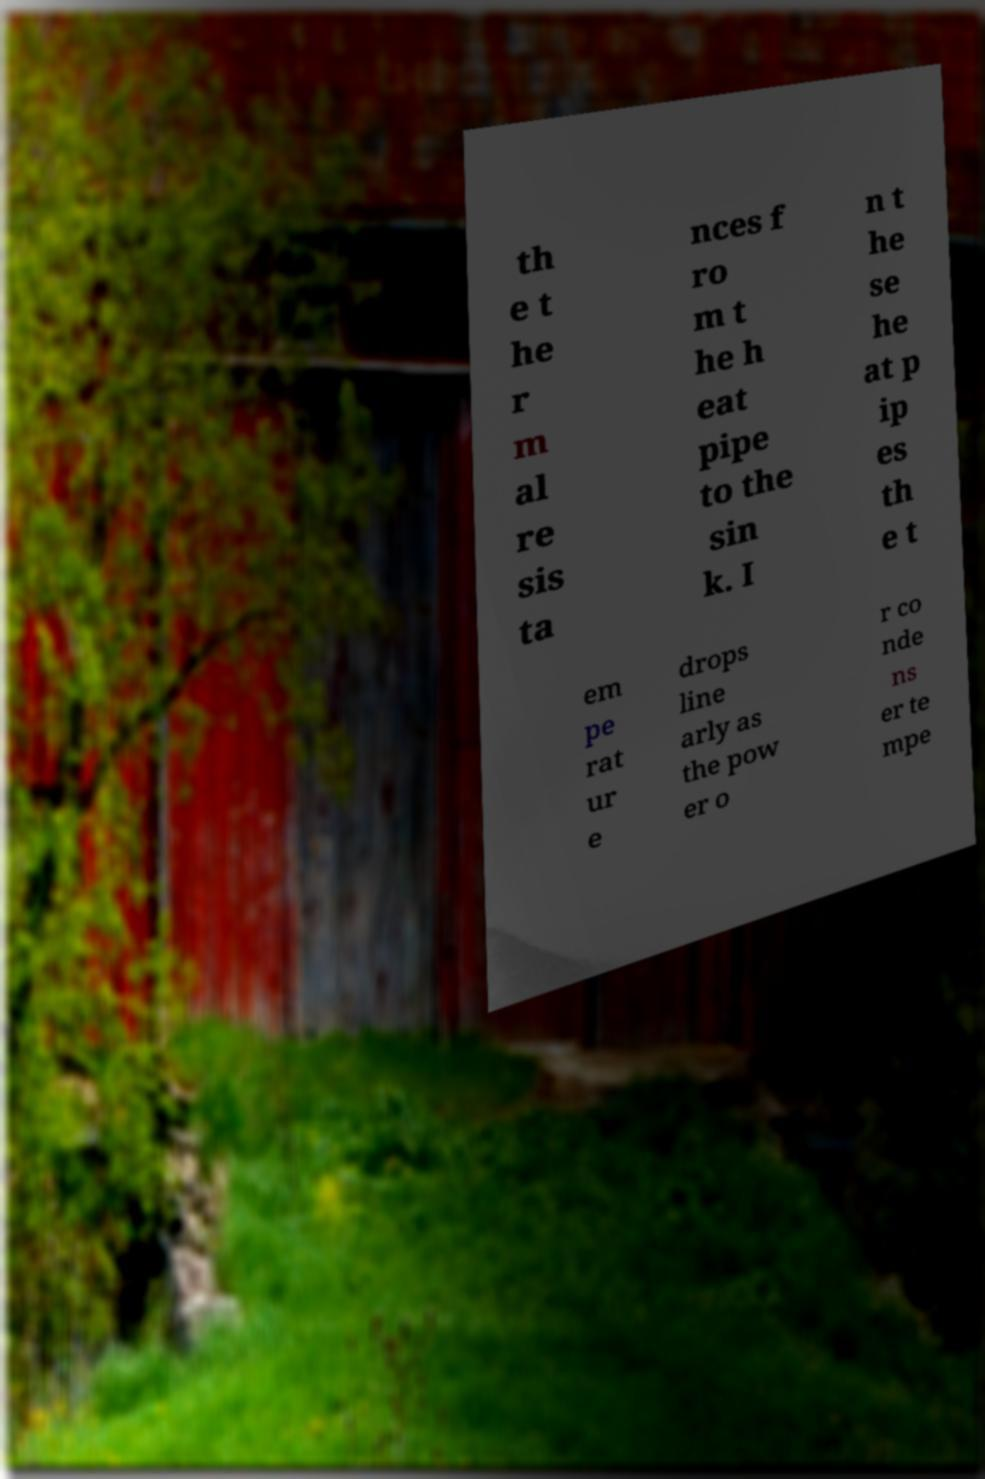I need the written content from this picture converted into text. Can you do that? th e t he r m al re sis ta nces f ro m t he h eat pipe to the sin k. I n t he se he at p ip es th e t em pe rat ur e drops line arly as the pow er o r co nde ns er te mpe 